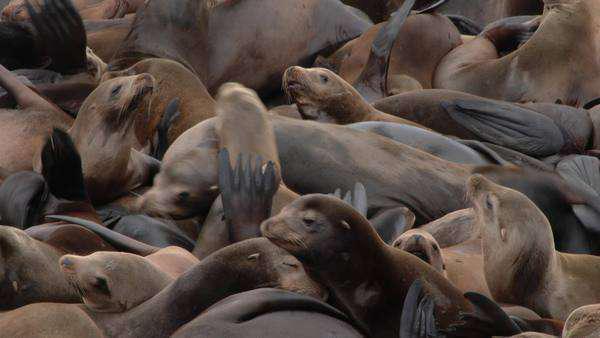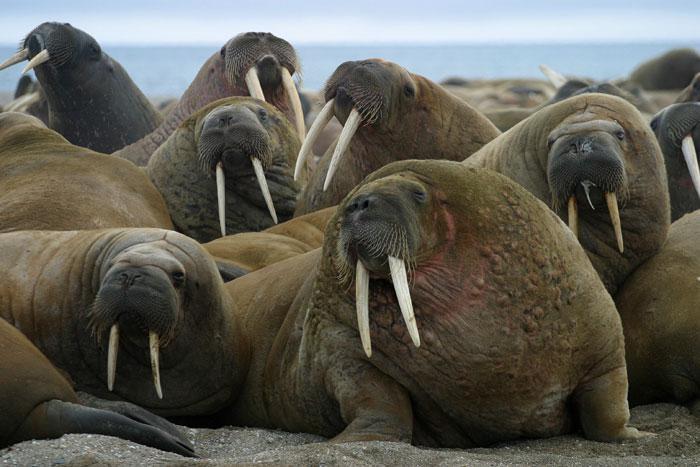The first image is the image on the left, the second image is the image on the right. Examine the images to the left and right. Is the description "Each image shows a mass of seals on a platform with brown vertical columns." accurate? Answer yes or no. No. The first image is the image on the left, the second image is the image on the right. Analyze the images presented: Is the assertion "In at least one of the images, there are visible holes in the edges of the floating dock." valid? Answer yes or no. No. 